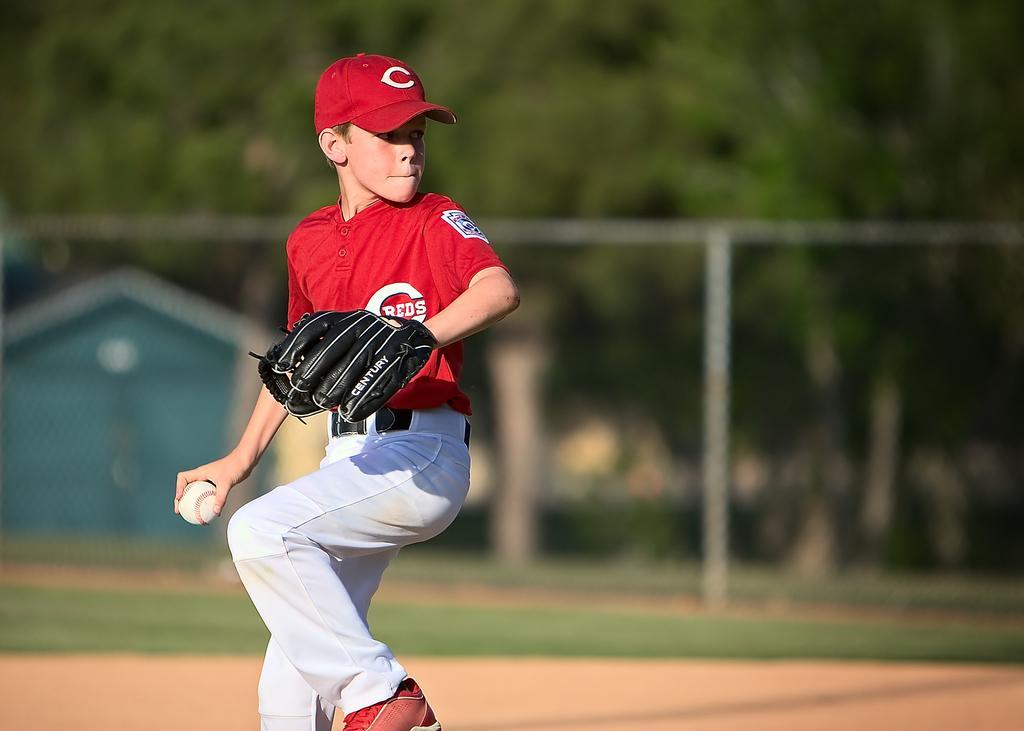In one or two sentences, can you explain what this image depicts? In this image we can see a boy holding a ball. Behind the boy we can see the grass and trees. The background of the image is blurred. 